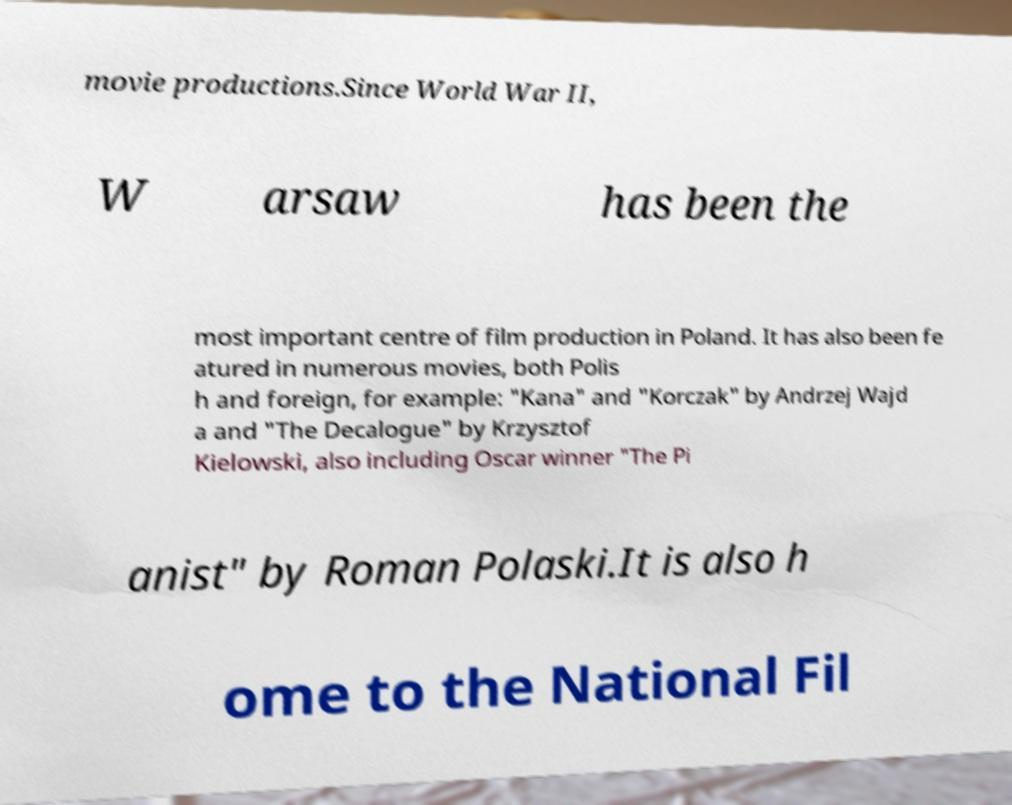There's text embedded in this image that I need extracted. Can you transcribe it verbatim? movie productions.Since World War II, W arsaw has been the most important centre of film production in Poland. It has also been fe atured in numerous movies, both Polis h and foreign, for example: "Kana" and "Korczak" by Andrzej Wajd a and "The Decalogue" by Krzysztof Kielowski, also including Oscar winner "The Pi anist" by Roman Polaski.It is also h ome to the National Fil 